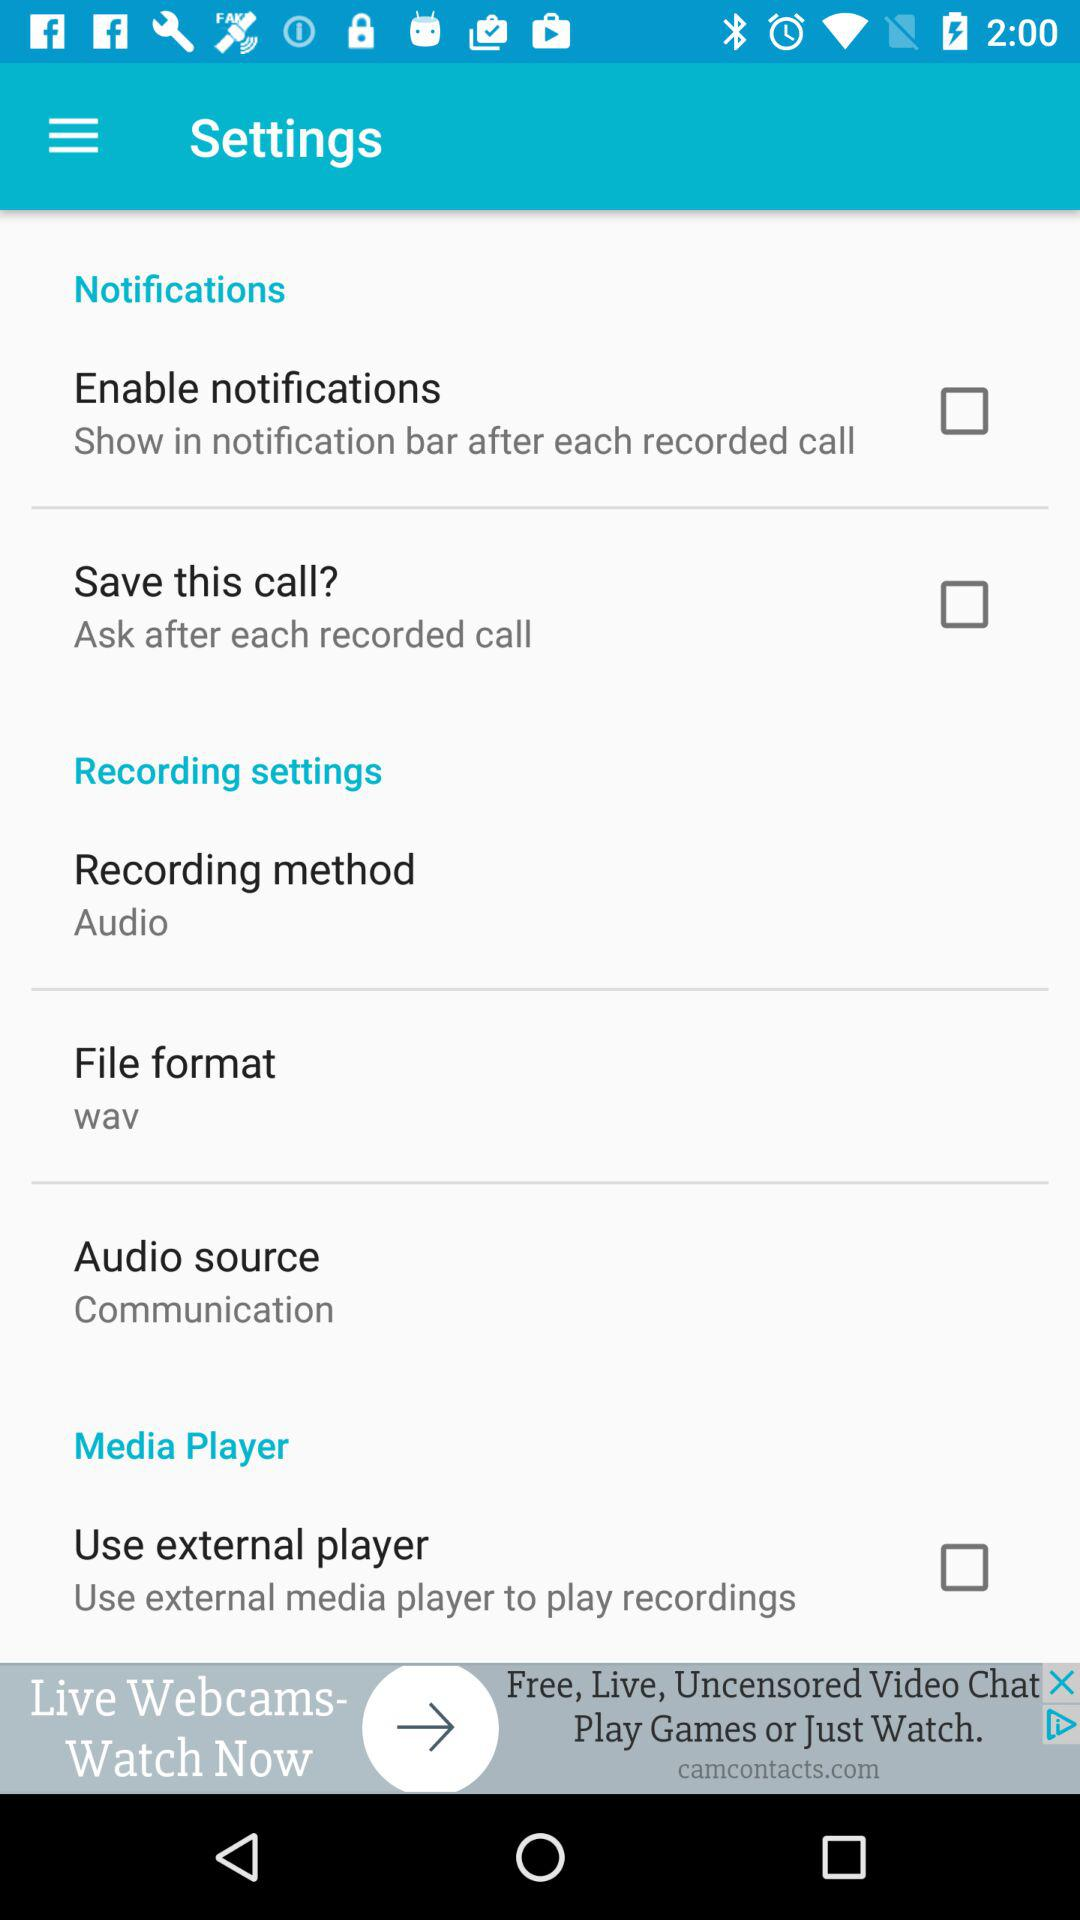What is the setting for the audio source? The setting is "Communication". 